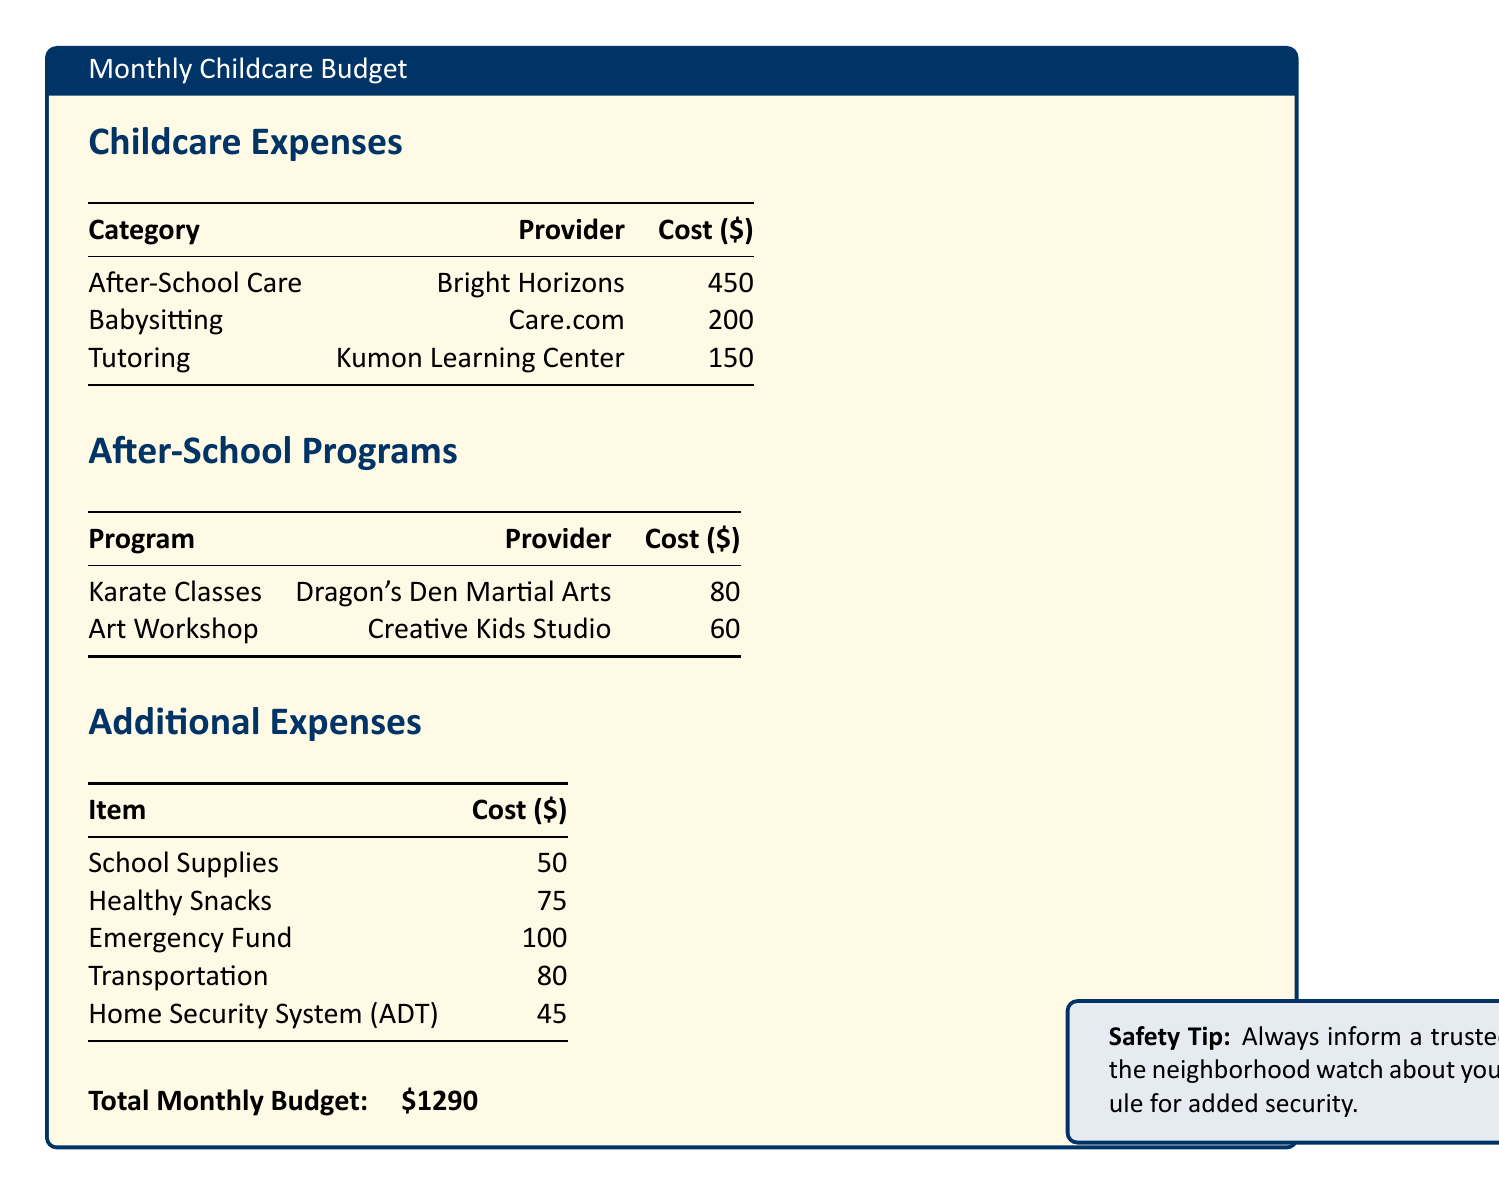What is the total monthly budget? The total monthly budget is specified at the end of the document as the sum of all expenses.
Answer: $1290 How much does Bright Horizons charge for after-school care? The cost for after-school care at Bright Horizons is listed in the document.
Answer: $450 What is the cost of emergency fund expenses? The emergency fund expense is detailed in the additional expenses section of the document.
Answer: $100 Which provider offers karate classes? The document lists the provider for karate classes under after-school programs.
Answer: Dragon's Den Martial Arts What are the total costs for after-school programs? The total is calculated by summing the individual program costs.
Answer: $140 How much is allocated for healthy snacks? The document specifies the cost allocated for healthy snacks in the additional expenses.
Answer: $75 Which service costs the most in the babysitting category? The document includes a comparison of the different provider costs in the childcare expenses.
Answer: Care.com What type of security system is mentioned in the document? The document refers to the type of security system included in the additional expenses.
Answer: ADT What is the cost of art workshop? The document specifies the cost for the art workshop in the after-school programs section.
Answer: $60 